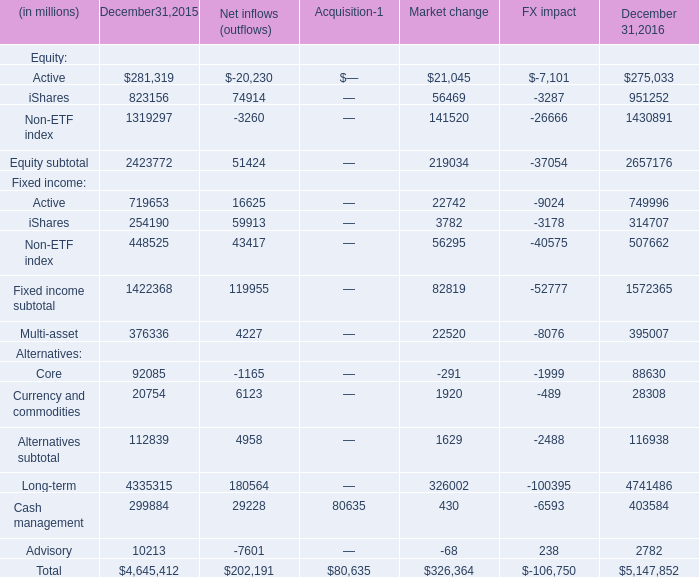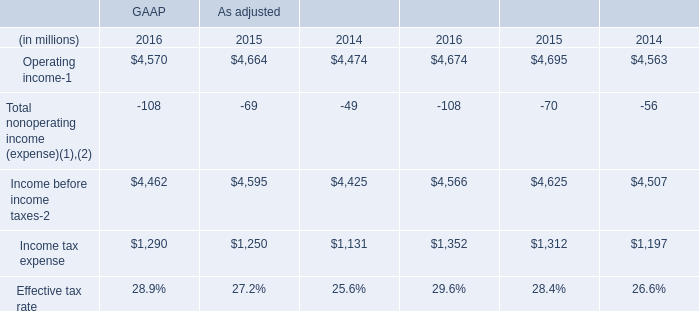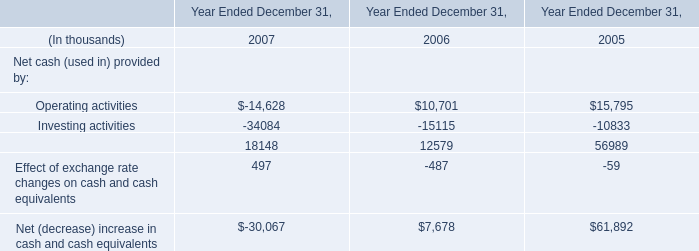What is the total amount of iShares of Market change, Operating income of As adjusted 2014, and iShares of December 31,2016 ? 
Computations: ((56469.0 + 4563.0) + 951252.0)
Answer: 1012284.0. 